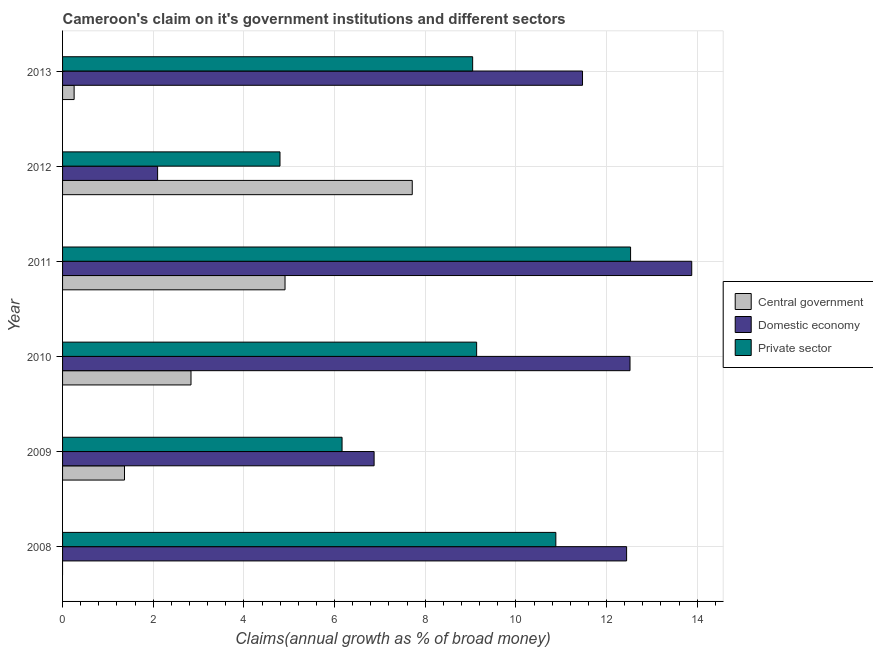How many different coloured bars are there?
Offer a terse response. 3. Are the number of bars per tick equal to the number of legend labels?
Give a very brief answer. No. How many bars are there on the 3rd tick from the bottom?
Your answer should be compact. 3. What is the label of the 2nd group of bars from the top?
Make the answer very short. 2012. What is the percentage of claim on the private sector in 2009?
Your answer should be compact. 6.17. Across all years, what is the maximum percentage of claim on the domestic economy?
Make the answer very short. 13.88. Across all years, what is the minimum percentage of claim on the central government?
Offer a terse response. 0. In which year was the percentage of claim on the central government maximum?
Give a very brief answer. 2012. What is the total percentage of claim on the domestic economy in the graph?
Offer a terse response. 59.28. What is the difference between the percentage of claim on the private sector in 2011 and that in 2013?
Offer a terse response. 3.48. What is the difference between the percentage of claim on the central government in 2008 and the percentage of claim on the private sector in 2013?
Give a very brief answer. -9.05. What is the average percentage of claim on the domestic economy per year?
Your answer should be very brief. 9.88. In the year 2012, what is the difference between the percentage of claim on the private sector and percentage of claim on the central government?
Ensure brevity in your answer.  -2.92. What is the ratio of the percentage of claim on the central government in 2012 to that in 2013?
Offer a very short reply. 30.25. Is the percentage of claim on the domestic economy in 2010 less than that in 2011?
Offer a terse response. Yes. Is the difference between the percentage of claim on the private sector in 2011 and 2012 greater than the difference between the percentage of claim on the central government in 2011 and 2012?
Give a very brief answer. Yes. What is the difference between the highest and the second highest percentage of claim on the central government?
Make the answer very short. 2.81. What is the difference between the highest and the lowest percentage of claim on the domestic economy?
Your answer should be very brief. 11.78. In how many years, is the percentage of claim on the private sector greater than the average percentage of claim on the private sector taken over all years?
Ensure brevity in your answer.  4. Is it the case that in every year, the sum of the percentage of claim on the central government and percentage of claim on the domestic economy is greater than the percentage of claim on the private sector?
Give a very brief answer. Yes. How many bars are there?
Give a very brief answer. 17. Are the values on the major ticks of X-axis written in scientific E-notation?
Offer a very short reply. No. Does the graph contain grids?
Provide a succinct answer. Yes. How many legend labels are there?
Provide a short and direct response. 3. What is the title of the graph?
Give a very brief answer. Cameroon's claim on it's government institutions and different sectors. What is the label or title of the X-axis?
Make the answer very short. Claims(annual growth as % of broad money). What is the label or title of the Y-axis?
Provide a succinct answer. Year. What is the Claims(annual growth as % of broad money) of Central government in 2008?
Offer a terse response. 0. What is the Claims(annual growth as % of broad money) in Domestic economy in 2008?
Make the answer very short. 12.44. What is the Claims(annual growth as % of broad money) in Private sector in 2008?
Make the answer very short. 10.88. What is the Claims(annual growth as % of broad money) of Central government in 2009?
Your answer should be compact. 1.37. What is the Claims(annual growth as % of broad money) in Domestic economy in 2009?
Offer a very short reply. 6.87. What is the Claims(annual growth as % of broad money) of Private sector in 2009?
Your response must be concise. 6.17. What is the Claims(annual growth as % of broad money) in Central government in 2010?
Keep it short and to the point. 2.83. What is the Claims(annual growth as % of broad money) in Domestic economy in 2010?
Offer a terse response. 12.52. What is the Claims(annual growth as % of broad money) in Private sector in 2010?
Ensure brevity in your answer.  9.13. What is the Claims(annual growth as % of broad money) of Central government in 2011?
Keep it short and to the point. 4.91. What is the Claims(annual growth as % of broad money) in Domestic economy in 2011?
Keep it short and to the point. 13.88. What is the Claims(annual growth as % of broad money) of Private sector in 2011?
Give a very brief answer. 12.53. What is the Claims(annual growth as % of broad money) of Central government in 2012?
Offer a very short reply. 7.71. What is the Claims(annual growth as % of broad money) in Domestic economy in 2012?
Offer a very short reply. 2.1. What is the Claims(annual growth as % of broad money) of Private sector in 2012?
Keep it short and to the point. 4.8. What is the Claims(annual growth as % of broad money) in Central government in 2013?
Offer a very short reply. 0.25. What is the Claims(annual growth as % of broad money) of Domestic economy in 2013?
Ensure brevity in your answer.  11.47. What is the Claims(annual growth as % of broad money) of Private sector in 2013?
Offer a very short reply. 9.05. Across all years, what is the maximum Claims(annual growth as % of broad money) in Central government?
Offer a terse response. 7.71. Across all years, what is the maximum Claims(annual growth as % of broad money) in Domestic economy?
Offer a terse response. 13.88. Across all years, what is the maximum Claims(annual growth as % of broad money) in Private sector?
Provide a short and direct response. 12.53. Across all years, what is the minimum Claims(annual growth as % of broad money) of Domestic economy?
Ensure brevity in your answer.  2.1. Across all years, what is the minimum Claims(annual growth as % of broad money) of Private sector?
Provide a succinct answer. 4.8. What is the total Claims(annual growth as % of broad money) of Central government in the graph?
Offer a very short reply. 17.08. What is the total Claims(annual growth as % of broad money) of Domestic economy in the graph?
Offer a very short reply. 59.28. What is the total Claims(annual growth as % of broad money) of Private sector in the graph?
Make the answer very short. 52.55. What is the difference between the Claims(annual growth as % of broad money) in Domestic economy in 2008 and that in 2009?
Provide a short and direct response. 5.57. What is the difference between the Claims(annual growth as % of broad money) in Private sector in 2008 and that in 2009?
Your response must be concise. 4.72. What is the difference between the Claims(annual growth as % of broad money) of Domestic economy in 2008 and that in 2010?
Offer a terse response. -0.08. What is the difference between the Claims(annual growth as % of broad money) of Private sector in 2008 and that in 2010?
Provide a succinct answer. 1.75. What is the difference between the Claims(annual growth as % of broad money) of Domestic economy in 2008 and that in 2011?
Your answer should be very brief. -1.44. What is the difference between the Claims(annual growth as % of broad money) in Private sector in 2008 and that in 2011?
Provide a short and direct response. -1.65. What is the difference between the Claims(annual growth as % of broad money) of Domestic economy in 2008 and that in 2012?
Provide a short and direct response. 10.35. What is the difference between the Claims(annual growth as % of broad money) in Private sector in 2008 and that in 2012?
Your answer should be very brief. 6.08. What is the difference between the Claims(annual growth as % of broad money) of Domestic economy in 2008 and that in 2013?
Your response must be concise. 0.97. What is the difference between the Claims(annual growth as % of broad money) in Private sector in 2008 and that in 2013?
Your answer should be compact. 1.83. What is the difference between the Claims(annual growth as % of broad money) in Central government in 2009 and that in 2010?
Your answer should be very brief. -1.47. What is the difference between the Claims(annual growth as % of broad money) in Domestic economy in 2009 and that in 2010?
Ensure brevity in your answer.  -5.64. What is the difference between the Claims(annual growth as % of broad money) in Private sector in 2009 and that in 2010?
Offer a terse response. -2.97. What is the difference between the Claims(annual growth as % of broad money) of Central government in 2009 and that in 2011?
Give a very brief answer. -3.54. What is the difference between the Claims(annual growth as % of broad money) of Domestic economy in 2009 and that in 2011?
Your answer should be compact. -7.01. What is the difference between the Claims(annual growth as % of broad money) of Private sector in 2009 and that in 2011?
Offer a terse response. -6.36. What is the difference between the Claims(annual growth as % of broad money) in Central government in 2009 and that in 2012?
Offer a terse response. -6.35. What is the difference between the Claims(annual growth as % of broad money) of Domestic economy in 2009 and that in 2012?
Ensure brevity in your answer.  4.78. What is the difference between the Claims(annual growth as % of broad money) of Private sector in 2009 and that in 2012?
Offer a terse response. 1.37. What is the difference between the Claims(annual growth as % of broad money) in Central government in 2009 and that in 2013?
Ensure brevity in your answer.  1.11. What is the difference between the Claims(annual growth as % of broad money) of Domestic economy in 2009 and that in 2013?
Your answer should be very brief. -4.6. What is the difference between the Claims(annual growth as % of broad money) in Private sector in 2009 and that in 2013?
Offer a very short reply. -2.88. What is the difference between the Claims(annual growth as % of broad money) in Central government in 2010 and that in 2011?
Provide a succinct answer. -2.07. What is the difference between the Claims(annual growth as % of broad money) in Domestic economy in 2010 and that in 2011?
Provide a short and direct response. -1.36. What is the difference between the Claims(annual growth as % of broad money) of Private sector in 2010 and that in 2011?
Your answer should be very brief. -3.4. What is the difference between the Claims(annual growth as % of broad money) in Central government in 2010 and that in 2012?
Make the answer very short. -4.88. What is the difference between the Claims(annual growth as % of broad money) of Domestic economy in 2010 and that in 2012?
Ensure brevity in your answer.  10.42. What is the difference between the Claims(annual growth as % of broad money) of Private sector in 2010 and that in 2012?
Give a very brief answer. 4.34. What is the difference between the Claims(annual growth as % of broad money) of Central government in 2010 and that in 2013?
Your answer should be compact. 2.58. What is the difference between the Claims(annual growth as % of broad money) of Domestic economy in 2010 and that in 2013?
Keep it short and to the point. 1.05. What is the difference between the Claims(annual growth as % of broad money) in Private sector in 2010 and that in 2013?
Your response must be concise. 0.09. What is the difference between the Claims(annual growth as % of broad money) of Central government in 2011 and that in 2012?
Make the answer very short. -2.81. What is the difference between the Claims(annual growth as % of broad money) of Domestic economy in 2011 and that in 2012?
Your answer should be very brief. 11.78. What is the difference between the Claims(annual growth as % of broad money) in Private sector in 2011 and that in 2012?
Provide a short and direct response. 7.73. What is the difference between the Claims(annual growth as % of broad money) of Central government in 2011 and that in 2013?
Make the answer very short. 4.65. What is the difference between the Claims(annual growth as % of broad money) of Domestic economy in 2011 and that in 2013?
Ensure brevity in your answer.  2.41. What is the difference between the Claims(annual growth as % of broad money) in Private sector in 2011 and that in 2013?
Offer a very short reply. 3.48. What is the difference between the Claims(annual growth as % of broad money) of Central government in 2012 and that in 2013?
Keep it short and to the point. 7.46. What is the difference between the Claims(annual growth as % of broad money) in Domestic economy in 2012 and that in 2013?
Your response must be concise. -9.37. What is the difference between the Claims(annual growth as % of broad money) in Private sector in 2012 and that in 2013?
Give a very brief answer. -4.25. What is the difference between the Claims(annual growth as % of broad money) of Domestic economy in 2008 and the Claims(annual growth as % of broad money) of Private sector in 2009?
Provide a short and direct response. 6.28. What is the difference between the Claims(annual growth as % of broad money) in Domestic economy in 2008 and the Claims(annual growth as % of broad money) in Private sector in 2010?
Keep it short and to the point. 3.31. What is the difference between the Claims(annual growth as % of broad money) in Domestic economy in 2008 and the Claims(annual growth as % of broad money) in Private sector in 2011?
Make the answer very short. -0.09. What is the difference between the Claims(annual growth as % of broad money) in Domestic economy in 2008 and the Claims(annual growth as % of broad money) in Private sector in 2012?
Your answer should be very brief. 7.65. What is the difference between the Claims(annual growth as % of broad money) of Domestic economy in 2008 and the Claims(annual growth as % of broad money) of Private sector in 2013?
Ensure brevity in your answer.  3.4. What is the difference between the Claims(annual growth as % of broad money) in Central government in 2009 and the Claims(annual growth as % of broad money) in Domestic economy in 2010?
Offer a very short reply. -11.15. What is the difference between the Claims(annual growth as % of broad money) in Central government in 2009 and the Claims(annual growth as % of broad money) in Private sector in 2010?
Provide a succinct answer. -7.77. What is the difference between the Claims(annual growth as % of broad money) of Domestic economy in 2009 and the Claims(annual growth as % of broad money) of Private sector in 2010?
Your answer should be very brief. -2.26. What is the difference between the Claims(annual growth as % of broad money) in Central government in 2009 and the Claims(annual growth as % of broad money) in Domestic economy in 2011?
Keep it short and to the point. -12.51. What is the difference between the Claims(annual growth as % of broad money) of Central government in 2009 and the Claims(annual growth as % of broad money) of Private sector in 2011?
Offer a very short reply. -11.16. What is the difference between the Claims(annual growth as % of broad money) of Domestic economy in 2009 and the Claims(annual growth as % of broad money) of Private sector in 2011?
Offer a very short reply. -5.66. What is the difference between the Claims(annual growth as % of broad money) of Central government in 2009 and the Claims(annual growth as % of broad money) of Domestic economy in 2012?
Provide a succinct answer. -0.73. What is the difference between the Claims(annual growth as % of broad money) in Central government in 2009 and the Claims(annual growth as % of broad money) in Private sector in 2012?
Offer a very short reply. -3.43. What is the difference between the Claims(annual growth as % of broad money) in Domestic economy in 2009 and the Claims(annual growth as % of broad money) in Private sector in 2012?
Provide a succinct answer. 2.08. What is the difference between the Claims(annual growth as % of broad money) in Central government in 2009 and the Claims(annual growth as % of broad money) in Domestic economy in 2013?
Your answer should be very brief. -10.1. What is the difference between the Claims(annual growth as % of broad money) of Central government in 2009 and the Claims(annual growth as % of broad money) of Private sector in 2013?
Make the answer very short. -7.68. What is the difference between the Claims(annual growth as % of broad money) of Domestic economy in 2009 and the Claims(annual growth as % of broad money) of Private sector in 2013?
Give a very brief answer. -2.17. What is the difference between the Claims(annual growth as % of broad money) in Central government in 2010 and the Claims(annual growth as % of broad money) in Domestic economy in 2011?
Provide a short and direct response. -11.05. What is the difference between the Claims(annual growth as % of broad money) in Central government in 2010 and the Claims(annual growth as % of broad money) in Private sector in 2011?
Provide a short and direct response. -9.7. What is the difference between the Claims(annual growth as % of broad money) in Domestic economy in 2010 and the Claims(annual growth as % of broad money) in Private sector in 2011?
Make the answer very short. -0.01. What is the difference between the Claims(annual growth as % of broad money) in Central government in 2010 and the Claims(annual growth as % of broad money) in Domestic economy in 2012?
Keep it short and to the point. 0.74. What is the difference between the Claims(annual growth as % of broad money) of Central government in 2010 and the Claims(annual growth as % of broad money) of Private sector in 2012?
Provide a short and direct response. -1.96. What is the difference between the Claims(annual growth as % of broad money) in Domestic economy in 2010 and the Claims(annual growth as % of broad money) in Private sector in 2012?
Your answer should be compact. 7.72. What is the difference between the Claims(annual growth as % of broad money) of Central government in 2010 and the Claims(annual growth as % of broad money) of Domestic economy in 2013?
Give a very brief answer. -8.64. What is the difference between the Claims(annual growth as % of broad money) of Central government in 2010 and the Claims(annual growth as % of broad money) of Private sector in 2013?
Provide a succinct answer. -6.21. What is the difference between the Claims(annual growth as % of broad money) of Domestic economy in 2010 and the Claims(annual growth as % of broad money) of Private sector in 2013?
Your response must be concise. 3.47. What is the difference between the Claims(annual growth as % of broad money) in Central government in 2011 and the Claims(annual growth as % of broad money) in Domestic economy in 2012?
Make the answer very short. 2.81. What is the difference between the Claims(annual growth as % of broad money) of Central government in 2011 and the Claims(annual growth as % of broad money) of Private sector in 2012?
Offer a terse response. 0.11. What is the difference between the Claims(annual growth as % of broad money) in Domestic economy in 2011 and the Claims(annual growth as % of broad money) in Private sector in 2012?
Provide a succinct answer. 9.08. What is the difference between the Claims(annual growth as % of broad money) of Central government in 2011 and the Claims(annual growth as % of broad money) of Domestic economy in 2013?
Your answer should be compact. -6.56. What is the difference between the Claims(annual growth as % of broad money) in Central government in 2011 and the Claims(annual growth as % of broad money) in Private sector in 2013?
Your answer should be compact. -4.14. What is the difference between the Claims(annual growth as % of broad money) of Domestic economy in 2011 and the Claims(annual growth as % of broad money) of Private sector in 2013?
Give a very brief answer. 4.83. What is the difference between the Claims(annual growth as % of broad money) in Central government in 2012 and the Claims(annual growth as % of broad money) in Domestic economy in 2013?
Offer a terse response. -3.76. What is the difference between the Claims(annual growth as % of broad money) in Central government in 2012 and the Claims(annual growth as % of broad money) in Private sector in 2013?
Ensure brevity in your answer.  -1.33. What is the difference between the Claims(annual growth as % of broad money) in Domestic economy in 2012 and the Claims(annual growth as % of broad money) in Private sector in 2013?
Your answer should be compact. -6.95. What is the average Claims(annual growth as % of broad money) in Central government per year?
Your response must be concise. 2.85. What is the average Claims(annual growth as % of broad money) of Domestic economy per year?
Offer a terse response. 9.88. What is the average Claims(annual growth as % of broad money) in Private sector per year?
Offer a terse response. 8.76. In the year 2008, what is the difference between the Claims(annual growth as % of broad money) of Domestic economy and Claims(annual growth as % of broad money) of Private sector?
Offer a very short reply. 1.56. In the year 2009, what is the difference between the Claims(annual growth as % of broad money) of Central government and Claims(annual growth as % of broad money) of Domestic economy?
Offer a terse response. -5.51. In the year 2009, what is the difference between the Claims(annual growth as % of broad money) of Central government and Claims(annual growth as % of broad money) of Private sector?
Offer a terse response. -4.8. In the year 2009, what is the difference between the Claims(annual growth as % of broad money) of Domestic economy and Claims(annual growth as % of broad money) of Private sector?
Keep it short and to the point. 0.71. In the year 2010, what is the difference between the Claims(annual growth as % of broad money) of Central government and Claims(annual growth as % of broad money) of Domestic economy?
Give a very brief answer. -9.68. In the year 2010, what is the difference between the Claims(annual growth as % of broad money) in Central government and Claims(annual growth as % of broad money) in Private sector?
Offer a terse response. -6.3. In the year 2010, what is the difference between the Claims(annual growth as % of broad money) of Domestic economy and Claims(annual growth as % of broad money) of Private sector?
Your response must be concise. 3.38. In the year 2011, what is the difference between the Claims(annual growth as % of broad money) in Central government and Claims(annual growth as % of broad money) in Domestic economy?
Ensure brevity in your answer.  -8.97. In the year 2011, what is the difference between the Claims(annual growth as % of broad money) in Central government and Claims(annual growth as % of broad money) in Private sector?
Your response must be concise. -7.62. In the year 2011, what is the difference between the Claims(annual growth as % of broad money) in Domestic economy and Claims(annual growth as % of broad money) in Private sector?
Your response must be concise. 1.35. In the year 2012, what is the difference between the Claims(annual growth as % of broad money) of Central government and Claims(annual growth as % of broad money) of Domestic economy?
Provide a succinct answer. 5.62. In the year 2012, what is the difference between the Claims(annual growth as % of broad money) in Central government and Claims(annual growth as % of broad money) in Private sector?
Your answer should be compact. 2.92. In the year 2012, what is the difference between the Claims(annual growth as % of broad money) of Domestic economy and Claims(annual growth as % of broad money) of Private sector?
Your answer should be compact. -2.7. In the year 2013, what is the difference between the Claims(annual growth as % of broad money) in Central government and Claims(annual growth as % of broad money) in Domestic economy?
Your answer should be compact. -11.21. In the year 2013, what is the difference between the Claims(annual growth as % of broad money) in Central government and Claims(annual growth as % of broad money) in Private sector?
Offer a terse response. -8.79. In the year 2013, what is the difference between the Claims(annual growth as % of broad money) in Domestic economy and Claims(annual growth as % of broad money) in Private sector?
Ensure brevity in your answer.  2.42. What is the ratio of the Claims(annual growth as % of broad money) in Domestic economy in 2008 to that in 2009?
Keep it short and to the point. 1.81. What is the ratio of the Claims(annual growth as % of broad money) of Private sector in 2008 to that in 2009?
Provide a short and direct response. 1.76. What is the ratio of the Claims(annual growth as % of broad money) in Private sector in 2008 to that in 2010?
Keep it short and to the point. 1.19. What is the ratio of the Claims(annual growth as % of broad money) of Domestic economy in 2008 to that in 2011?
Give a very brief answer. 0.9. What is the ratio of the Claims(annual growth as % of broad money) in Private sector in 2008 to that in 2011?
Keep it short and to the point. 0.87. What is the ratio of the Claims(annual growth as % of broad money) of Domestic economy in 2008 to that in 2012?
Provide a succinct answer. 5.93. What is the ratio of the Claims(annual growth as % of broad money) in Private sector in 2008 to that in 2012?
Provide a succinct answer. 2.27. What is the ratio of the Claims(annual growth as % of broad money) of Domestic economy in 2008 to that in 2013?
Your answer should be very brief. 1.08. What is the ratio of the Claims(annual growth as % of broad money) in Private sector in 2008 to that in 2013?
Give a very brief answer. 1.2. What is the ratio of the Claims(annual growth as % of broad money) in Central government in 2009 to that in 2010?
Ensure brevity in your answer.  0.48. What is the ratio of the Claims(annual growth as % of broad money) of Domestic economy in 2009 to that in 2010?
Your answer should be compact. 0.55. What is the ratio of the Claims(annual growth as % of broad money) of Private sector in 2009 to that in 2010?
Provide a short and direct response. 0.68. What is the ratio of the Claims(annual growth as % of broad money) in Central government in 2009 to that in 2011?
Offer a terse response. 0.28. What is the ratio of the Claims(annual growth as % of broad money) in Domestic economy in 2009 to that in 2011?
Provide a succinct answer. 0.5. What is the ratio of the Claims(annual growth as % of broad money) in Private sector in 2009 to that in 2011?
Your answer should be compact. 0.49. What is the ratio of the Claims(annual growth as % of broad money) in Central government in 2009 to that in 2012?
Make the answer very short. 0.18. What is the ratio of the Claims(annual growth as % of broad money) in Domestic economy in 2009 to that in 2012?
Make the answer very short. 3.28. What is the ratio of the Claims(annual growth as % of broad money) in Private sector in 2009 to that in 2012?
Your answer should be compact. 1.29. What is the ratio of the Claims(annual growth as % of broad money) of Central government in 2009 to that in 2013?
Ensure brevity in your answer.  5.36. What is the ratio of the Claims(annual growth as % of broad money) of Domestic economy in 2009 to that in 2013?
Keep it short and to the point. 0.6. What is the ratio of the Claims(annual growth as % of broad money) in Private sector in 2009 to that in 2013?
Give a very brief answer. 0.68. What is the ratio of the Claims(annual growth as % of broad money) in Central government in 2010 to that in 2011?
Offer a terse response. 0.58. What is the ratio of the Claims(annual growth as % of broad money) of Domestic economy in 2010 to that in 2011?
Your response must be concise. 0.9. What is the ratio of the Claims(annual growth as % of broad money) of Private sector in 2010 to that in 2011?
Your answer should be very brief. 0.73. What is the ratio of the Claims(annual growth as % of broad money) in Central government in 2010 to that in 2012?
Offer a terse response. 0.37. What is the ratio of the Claims(annual growth as % of broad money) of Domestic economy in 2010 to that in 2012?
Your answer should be compact. 5.97. What is the ratio of the Claims(annual growth as % of broad money) of Private sector in 2010 to that in 2012?
Provide a succinct answer. 1.9. What is the ratio of the Claims(annual growth as % of broad money) in Central government in 2010 to that in 2013?
Your answer should be very brief. 11.11. What is the ratio of the Claims(annual growth as % of broad money) in Domestic economy in 2010 to that in 2013?
Provide a short and direct response. 1.09. What is the ratio of the Claims(annual growth as % of broad money) in Private sector in 2010 to that in 2013?
Provide a short and direct response. 1.01. What is the ratio of the Claims(annual growth as % of broad money) in Central government in 2011 to that in 2012?
Make the answer very short. 0.64. What is the ratio of the Claims(annual growth as % of broad money) of Domestic economy in 2011 to that in 2012?
Provide a short and direct response. 6.62. What is the ratio of the Claims(annual growth as % of broad money) in Private sector in 2011 to that in 2012?
Provide a short and direct response. 2.61. What is the ratio of the Claims(annual growth as % of broad money) in Central government in 2011 to that in 2013?
Your answer should be compact. 19.25. What is the ratio of the Claims(annual growth as % of broad money) of Domestic economy in 2011 to that in 2013?
Provide a succinct answer. 1.21. What is the ratio of the Claims(annual growth as % of broad money) in Private sector in 2011 to that in 2013?
Provide a succinct answer. 1.39. What is the ratio of the Claims(annual growth as % of broad money) of Central government in 2012 to that in 2013?
Your answer should be compact. 30.25. What is the ratio of the Claims(annual growth as % of broad money) of Domestic economy in 2012 to that in 2013?
Ensure brevity in your answer.  0.18. What is the ratio of the Claims(annual growth as % of broad money) of Private sector in 2012 to that in 2013?
Give a very brief answer. 0.53. What is the difference between the highest and the second highest Claims(annual growth as % of broad money) in Central government?
Keep it short and to the point. 2.81. What is the difference between the highest and the second highest Claims(annual growth as % of broad money) in Domestic economy?
Make the answer very short. 1.36. What is the difference between the highest and the second highest Claims(annual growth as % of broad money) of Private sector?
Your answer should be very brief. 1.65. What is the difference between the highest and the lowest Claims(annual growth as % of broad money) of Central government?
Your response must be concise. 7.71. What is the difference between the highest and the lowest Claims(annual growth as % of broad money) in Domestic economy?
Provide a succinct answer. 11.78. What is the difference between the highest and the lowest Claims(annual growth as % of broad money) of Private sector?
Give a very brief answer. 7.73. 